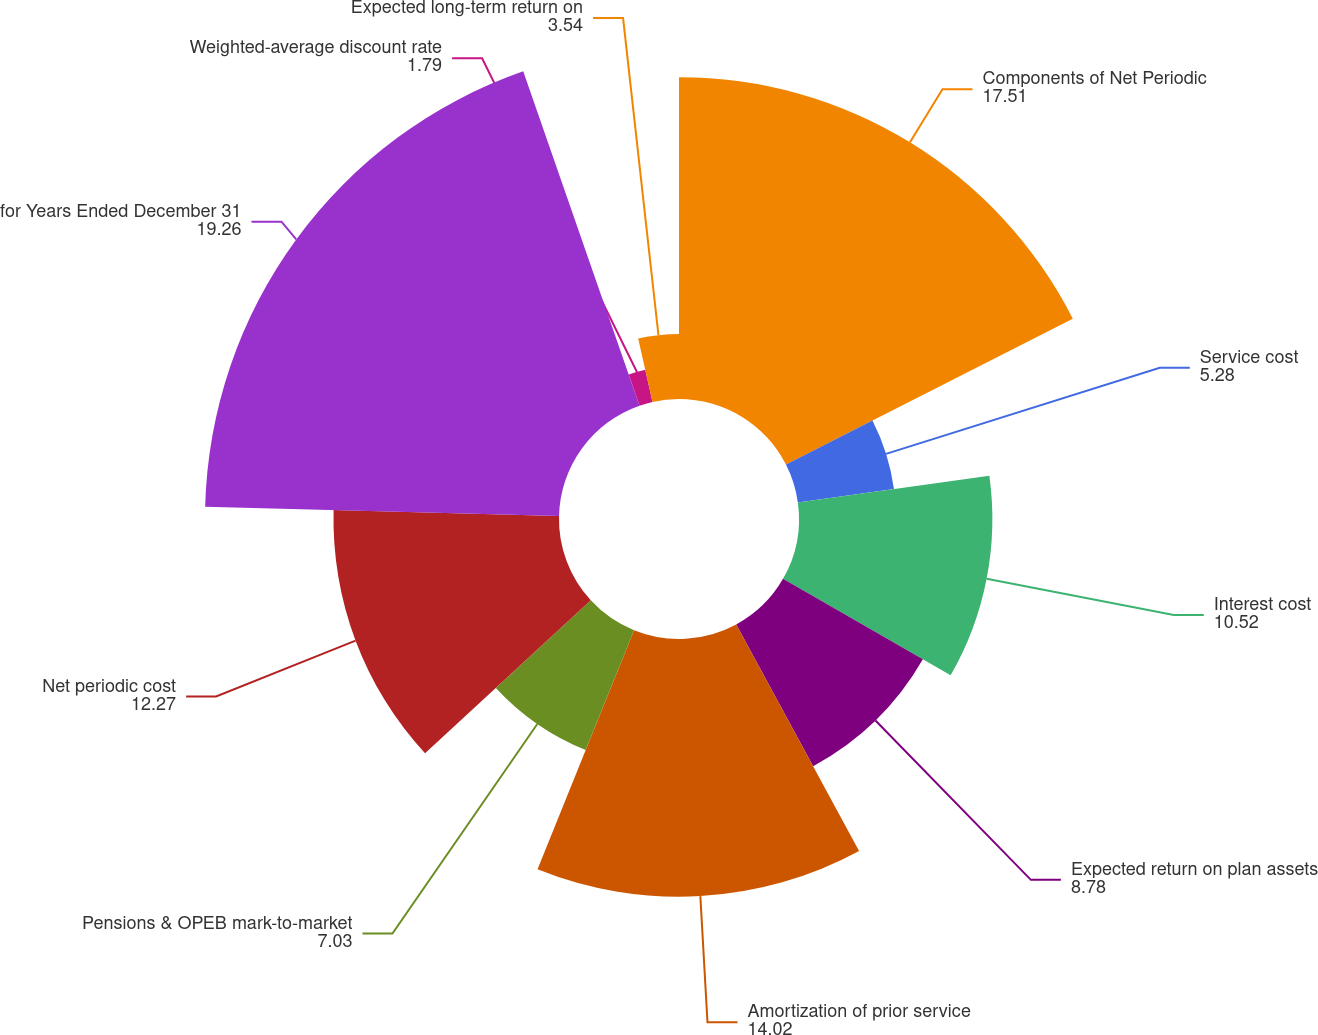Convert chart. <chart><loc_0><loc_0><loc_500><loc_500><pie_chart><fcel>Components of Net Periodic<fcel>Service cost<fcel>Interest cost<fcel>Expected return on plan assets<fcel>Amortization of prior service<fcel>Pensions & OPEB mark-to-market<fcel>Net periodic cost<fcel>for Years Ended December 31<fcel>Weighted-average discount rate<fcel>Expected long-term return on<nl><fcel>17.51%<fcel>5.28%<fcel>10.52%<fcel>8.78%<fcel>14.02%<fcel>7.03%<fcel>12.27%<fcel>19.26%<fcel>1.79%<fcel>3.54%<nl></chart> 